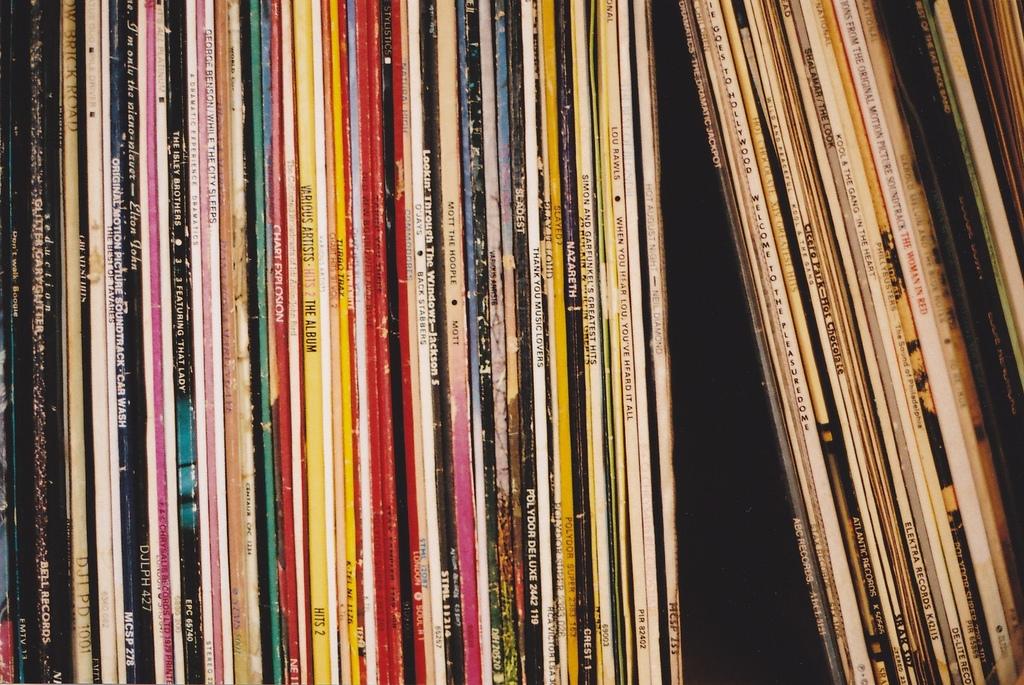What is one of the artists?
Give a very brief answer. Jackson 5. 